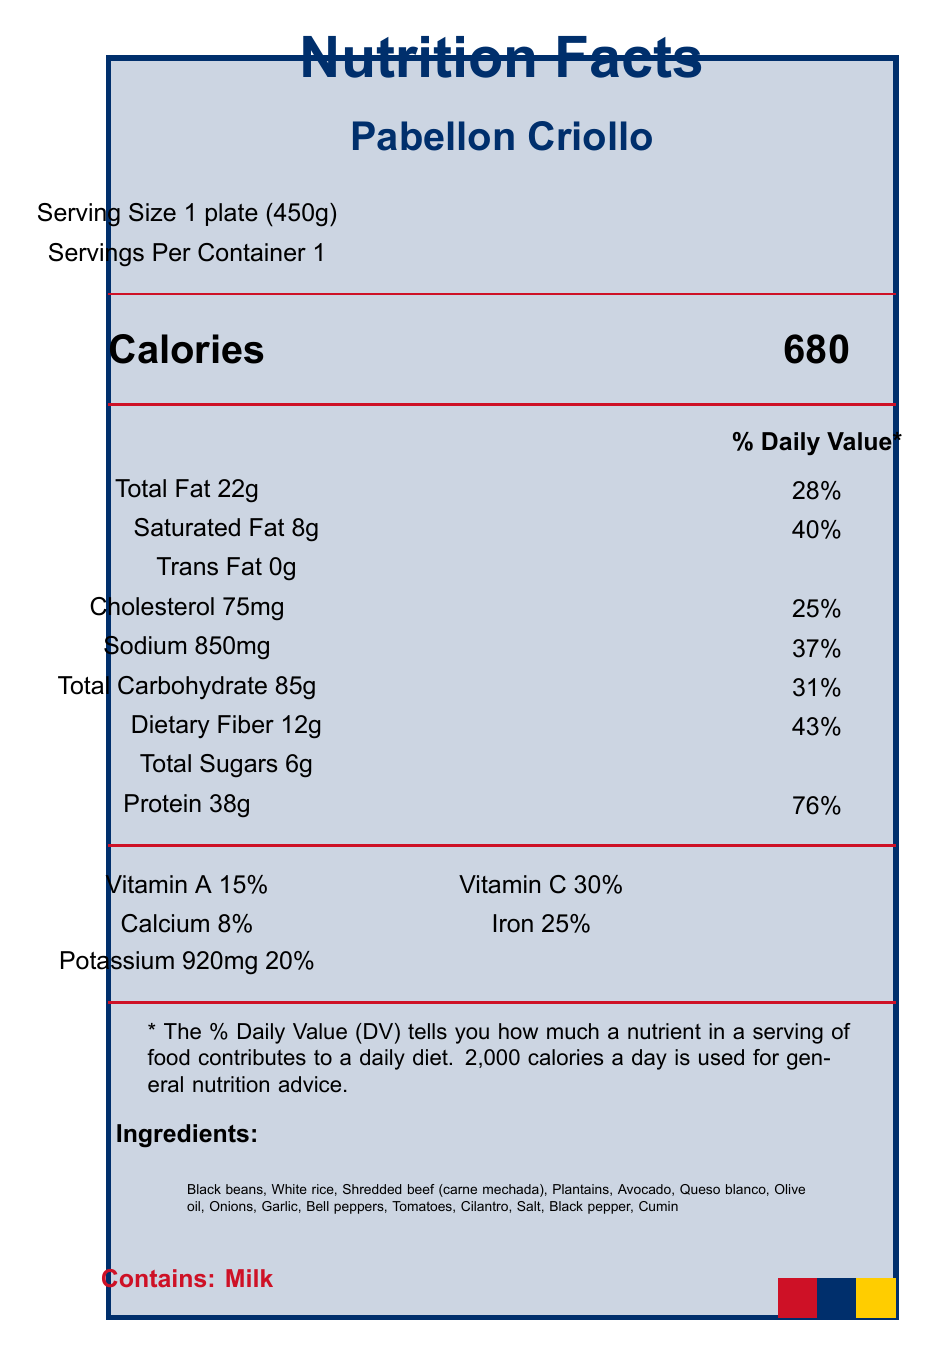what is the serving size of Pabellon Criollo? The serving size is explicitly mentioned as "1 plate (450g)" under the Serving information section.
Answer: 1 plate (450g) how many calories does one serving of Pabellon Criollo contain? The document lists the calories as 680 under the Calories section.
Answer: 680 what is the total fat content in one serving? Total Fat is listed as 22g under the Nutrient information section.
Answer: 22g how much dietary fiber does one serving of Pabellon Criollo provide? The document indicates "Dietary Fiber 12g" under the Total Carbohydrate section.
Answer: 12g which vitamin has the highest percentage daily value in Pabellon Criollo? The highest percentage daily value is listed as 30% for Vitamin C under the vitamin section.
Answer: Vitamin C how much sodium is in one serving of Pabellon Criollo? Sodium is noted as 850mg under the Nutrient information section.
Answer: 850mg what percentage of the daily value for protein does one serving contribute? Protein is listed with a daily value percentage of 76% in the Nutrient information section.
Answer: 76% what allergens are present in Pabellon Criollo? The document clearly states "Contains: Milk" under the Allergens section.
Answer: Milk how is Pabellon Criollo traditionally prepared? The traditional preparation method is described in the traditional preparation method section.
Answer: Slow-cooked beef, stewed black beans, and fried plantains served over white rice. Often accompanied by arepas. where is Pabellon Criollo commonly available in Venezuela? A. Caracas and central Venezuela B. Western Venezuela C. Eastern Venezuela D. Throughout South America According to the regional availability section, it is most common in Caracas and central Venezuela.
Answer: A. Caracas and central Venezuela which nutrient has the lowest percentage daily value in Pabellon Criollo? A. Iron B. Vitamin A C. Vitamin C D. Calcium The document shows that Calcium has an 8% daily value, which is the lowest compared to others like Iron (25%), Vitamin A (15%), and Vitamin C (30%).
Answer: D. Calcium is Pabellon Criollo high in protein? The document indicates that one serving contains 38g of protein, which is 76% of the daily value, categorizing it as high in protein.
Answer: Yes summarize the nutritional benefits of Pabellon Criollo mentioned in the document. The document provides information on the nutritional benefits, listing these key points under the nutritional benefits section.
Answer: Pabellon Criollo is high in protein, fiber, and complex carbohydrates. It is also a good source of iron and potassium. how long does it take to prepare Pabellon Criollo? The document does not provide any details or timing on the preparation duration for the dish.
Answer: Not enough information 